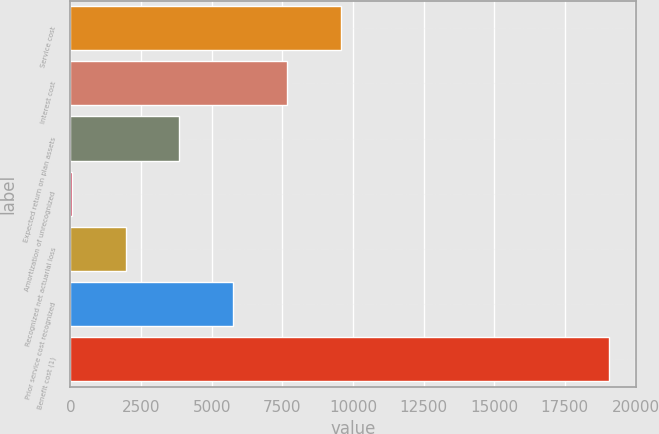Convert chart. <chart><loc_0><loc_0><loc_500><loc_500><bar_chart><fcel>Service cost<fcel>Interest cost<fcel>Expected return on plan assets<fcel>Amortization of unrecognized<fcel>Recognized net actuarial loss<fcel>Prior service cost recognized<fcel>Benefit cost (1)<nl><fcel>9567<fcel>7665<fcel>3861<fcel>57<fcel>1959<fcel>5763<fcel>19077<nl></chart> 